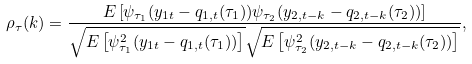Convert formula to latex. <formula><loc_0><loc_0><loc_500><loc_500>\rho _ { \tau } ( k ) = \frac { E \left [ \psi _ { \tau _ { 1 } } ( y _ { 1 t } - q _ { 1 , t } ( \tau _ { 1 } ) ) \psi _ { \tau _ { 2 } } ( y _ { 2 , t - k } - q _ { 2 , t - k } ( \tau _ { 2 } ) ) \right ] } { \sqrt { E \left [ \psi _ { \tau _ { 1 } } ^ { 2 } ( y _ { 1 t } - q _ { 1 , t } ( \tau _ { 1 } ) ) \right ] } \sqrt { E \left [ \psi _ { \tau _ { 2 } } ^ { 2 } ( y _ { 2 , t - k } - q _ { 2 , t - k } ( \tau _ { 2 } ) ) \right ] } } ,</formula> 